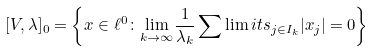<formula> <loc_0><loc_0><loc_500><loc_500>[ V , \lambda ] _ { 0 } = \left \{ x \in \ell ^ { 0 } \colon \underset { k \rightarrow \infty } { \lim } \frac { 1 } { \lambda _ { k } } \sum \lim i t s _ { j \in I _ { k } } | x _ { j } | = 0 \right \}</formula> 